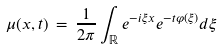<formula> <loc_0><loc_0><loc_500><loc_500>\mu ( x , t ) \, = \, \frac { 1 } { 2 \pi } \int _ { \mathbb { R } } e ^ { - i \xi x } e ^ { - t \varphi ( \xi ) } d \xi</formula> 